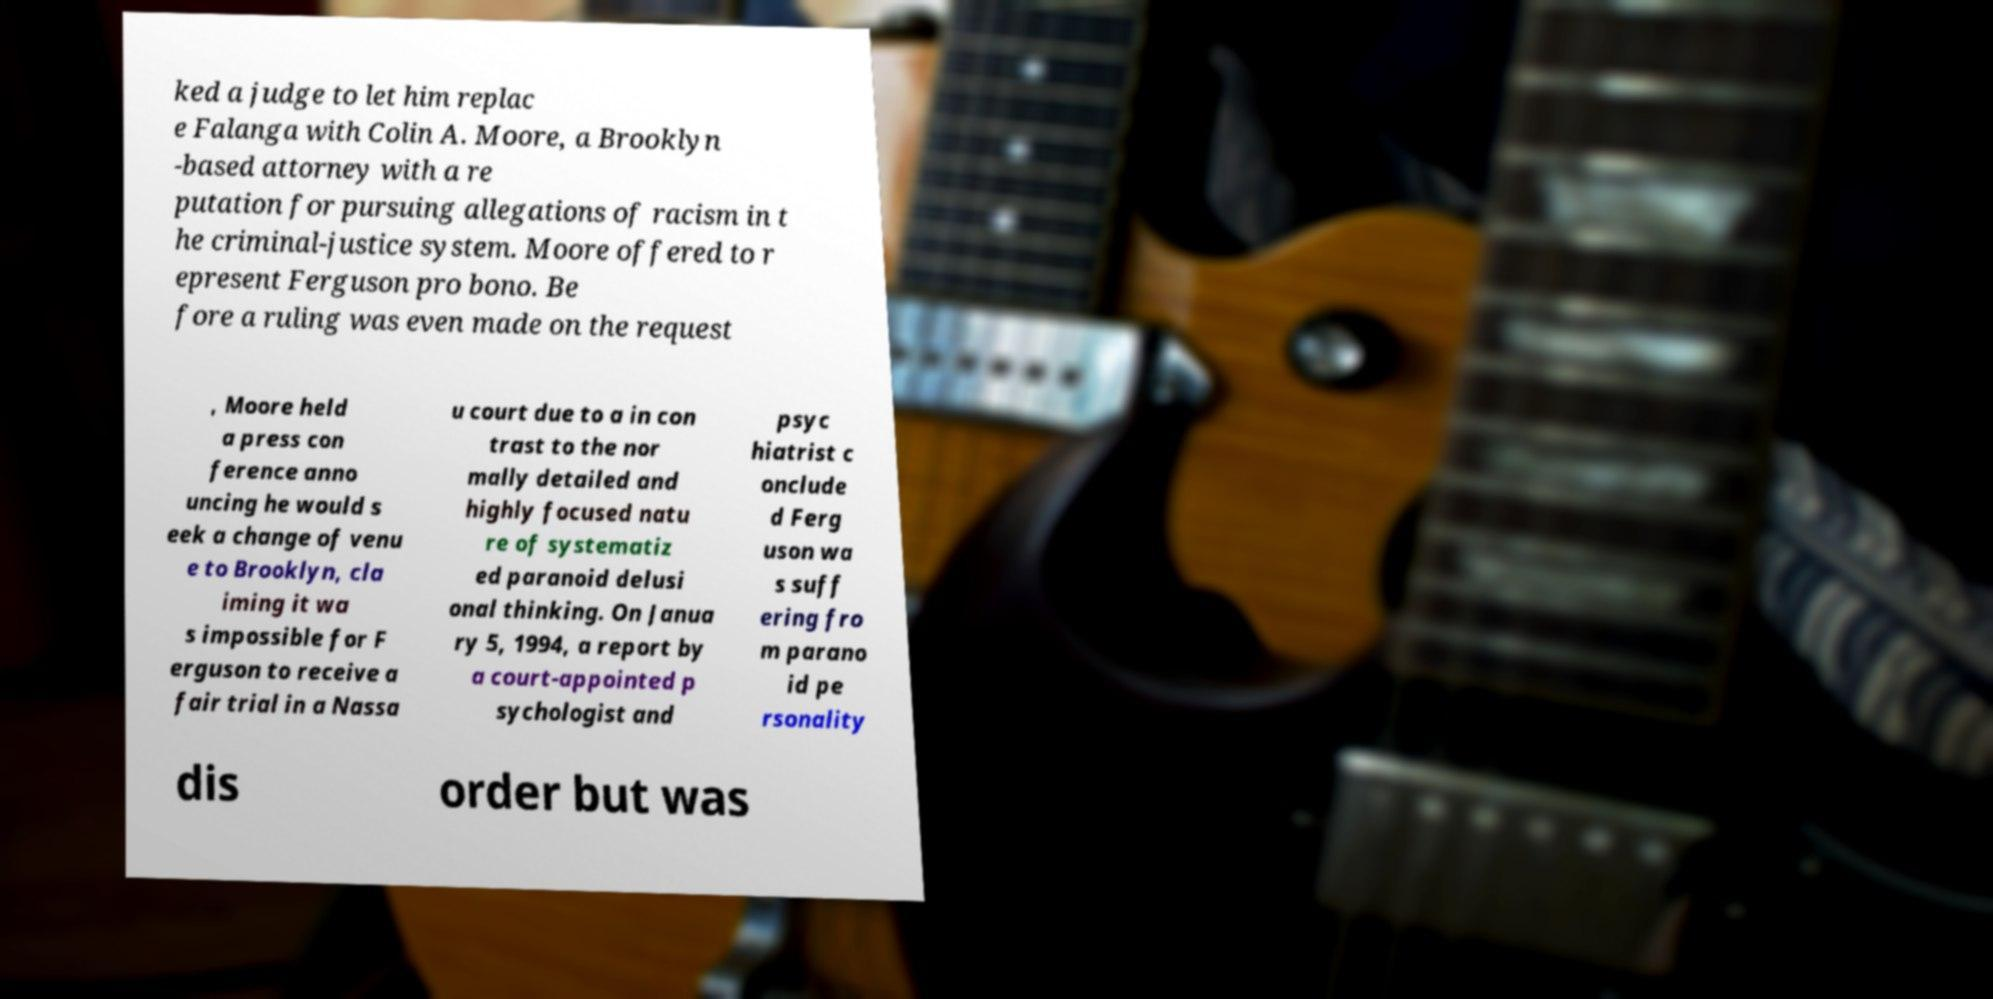What messages or text are displayed in this image? I need them in a readable, typed format. ked a judge to let him replac e Falanga with Colin A. Moore, a Brooklyn -based attorney with a re putation for pursuing allegations of racism in t he criminal-justice system. Moore offered to r epresent Ferguson pro bono. Be fore a ruling was even made on the request , Moore held a press con ference anno uncing he would s eek a change of venu e to Brooklyn, cla iming it wa s impossible for F erguson to receive a fair trial in a Nassa u court due to a in con trast to the nor mally detailed and highly focused natu re of systematiz ed paranoid delusi onal thinking. On Janua ry 5, 1994, a report by a court-appointed p sychologist and psyc hiatrist c onclude d Ferg uson wa s suff ering fro m parano id pe rsonality dis order but was 